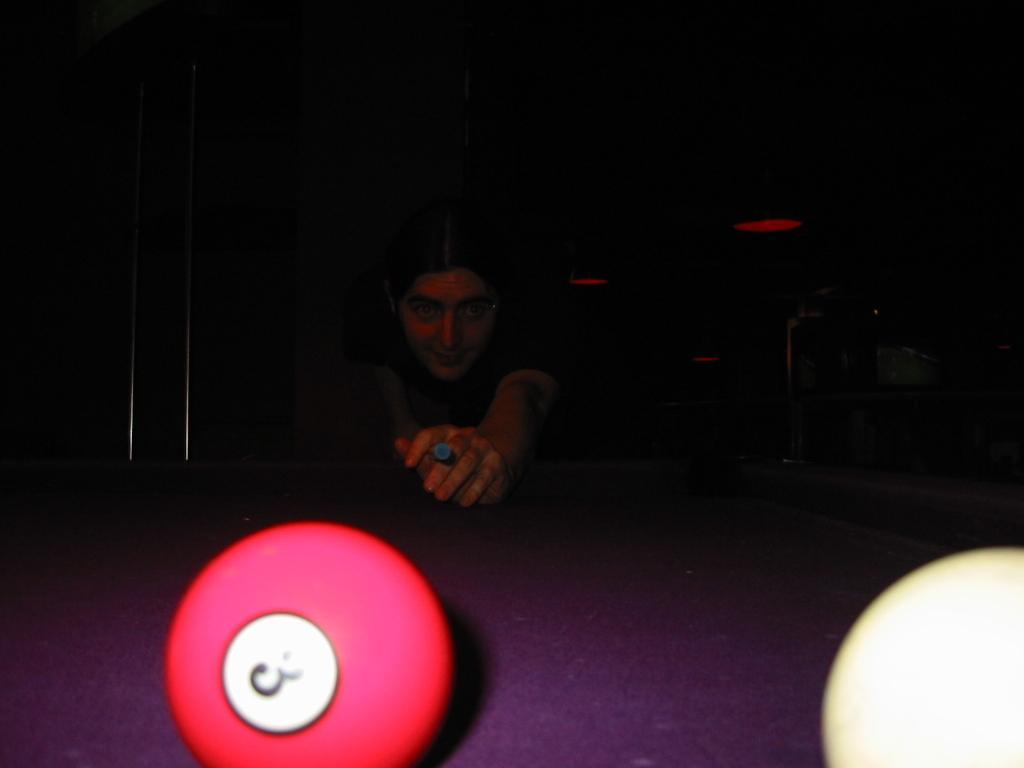In one or two sentences, can you explain what this image depicts? In this image I can see a person playing snookers. I can see two snooker balls at the bottom of the image on a table and the background is dark. 